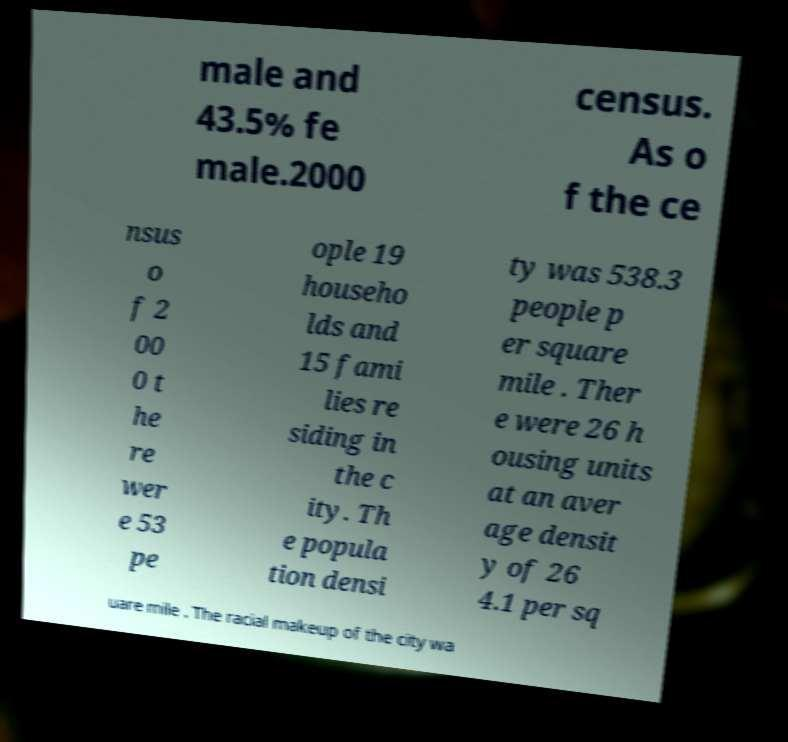Could you extract and type out the text from this image? male and 43.5% fe male.2000 census. As o f the ce nsus o f 2 00 0 t he re wer e 53 pe ople 19 househo lds and 15 fami lies re siding in the c ity. Th e popula tion densi ty was 538.3 people p er square mile . Ther e were 26 h ousing units at an aver age densit y of 26 4.1 per sq uare mile . The racial makeup of the city wa 